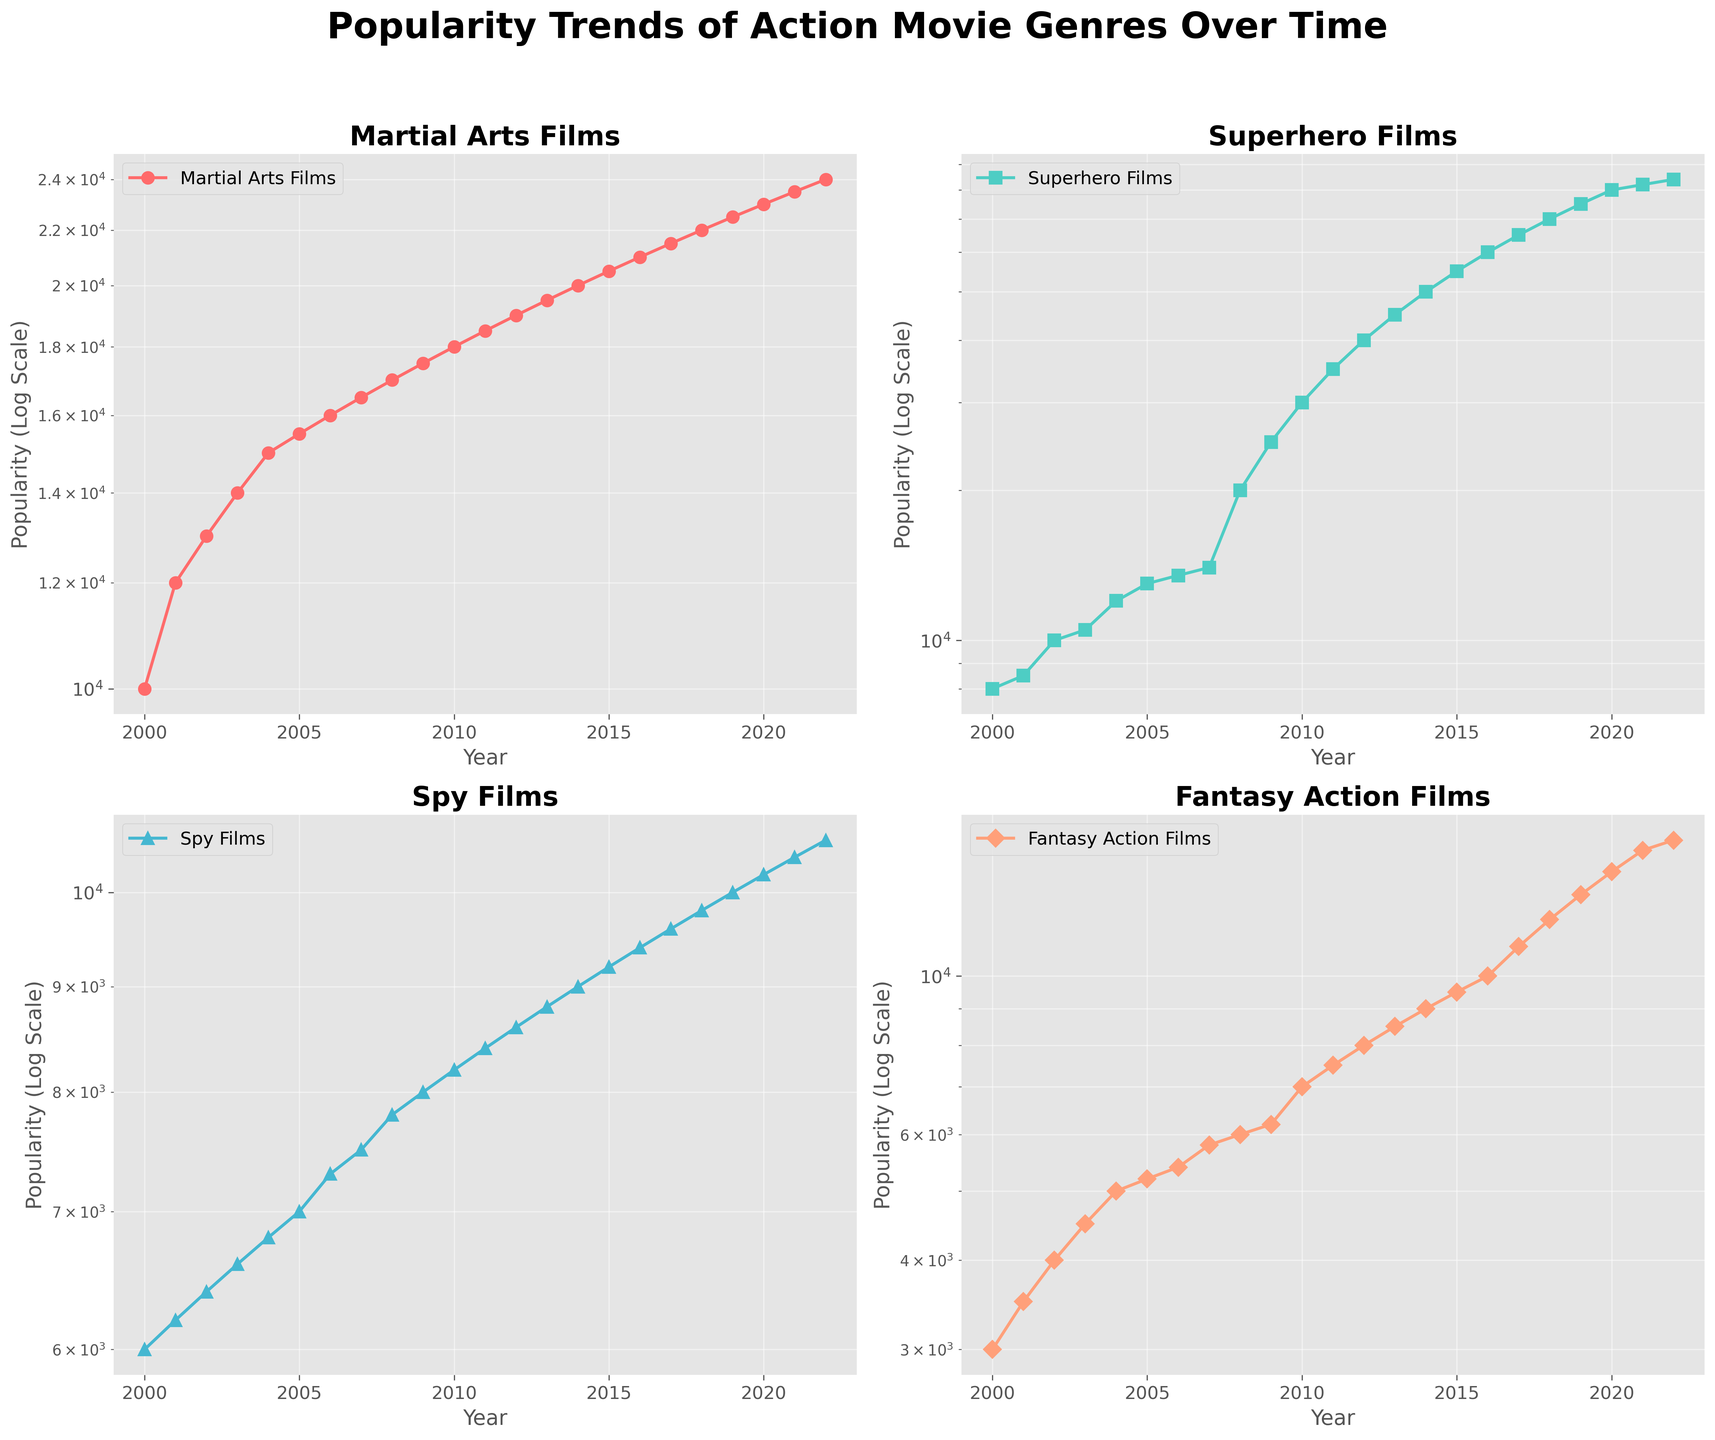what is the title of the figure? The title is written clearly at the top center of the figure.
Answer: Popularity Trends of Action Movie Genres Over Time which genre shows the highest increase in popularity over time? By observing the subplots, you can see that the subplot for Superhero Films has the steepest slope, indicating the highest increase in popularity.
Answer: Superhero Films does any genre show a decline in popularity over time? None of the subplots show a downward trend; all genres have increasing popularity over time.
Answer: No how many genres are represented in the subplots? Each subplot represents one genre, and there are 4 subplots in total.
Answer: 4 which genre had the highest popularity in the year 2022? In the year 2022, you can see the data points on the rightmost side of each subplot. The highest value is observed in the subplot for Superhero Films.
Answer: Superhero Films what was the popularity of Martial Arts Films in the year 2000? By looking at the leftmost data point on the Martial Arts Films subplot, you can see the popularity value.
Answer: 10,000 between what years did Fantasy Action Films have a sudden growth increase, compared to the previous periods? By observing the subplot for Fantasy Action Films, there is a noticeable steeper increase between the years 2017 and 2022 compared to earlier periods.
Answer: 2017-2022 which year marks the beginning of a significant rise in popularity for Superhero Films? The subplot for Superhero Films shows a noticeable steep rise starting around the year 2008.
Answer: 2008 compare the popularity of Spy Films and Fantasy Action Films in 2010. which was more popular? By examining the data points for the year 2010 in each subplot, Spy Films had a popularity of 8,200, and Fantasy Action Films had 7,000. Spy Films was more popular in 2010.
Answer: Spy Films what is the general trend of all the genres over time? All subplots show a general upward trend over the years, indicating an increase in popularity for all genres over time.
Answer: Increasing 